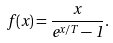<formula> <loc_0><loc_0><loc_500><loc_500>f ( x ) = \frac { x } { e ^ { x / T } - 1 } .</formula> 